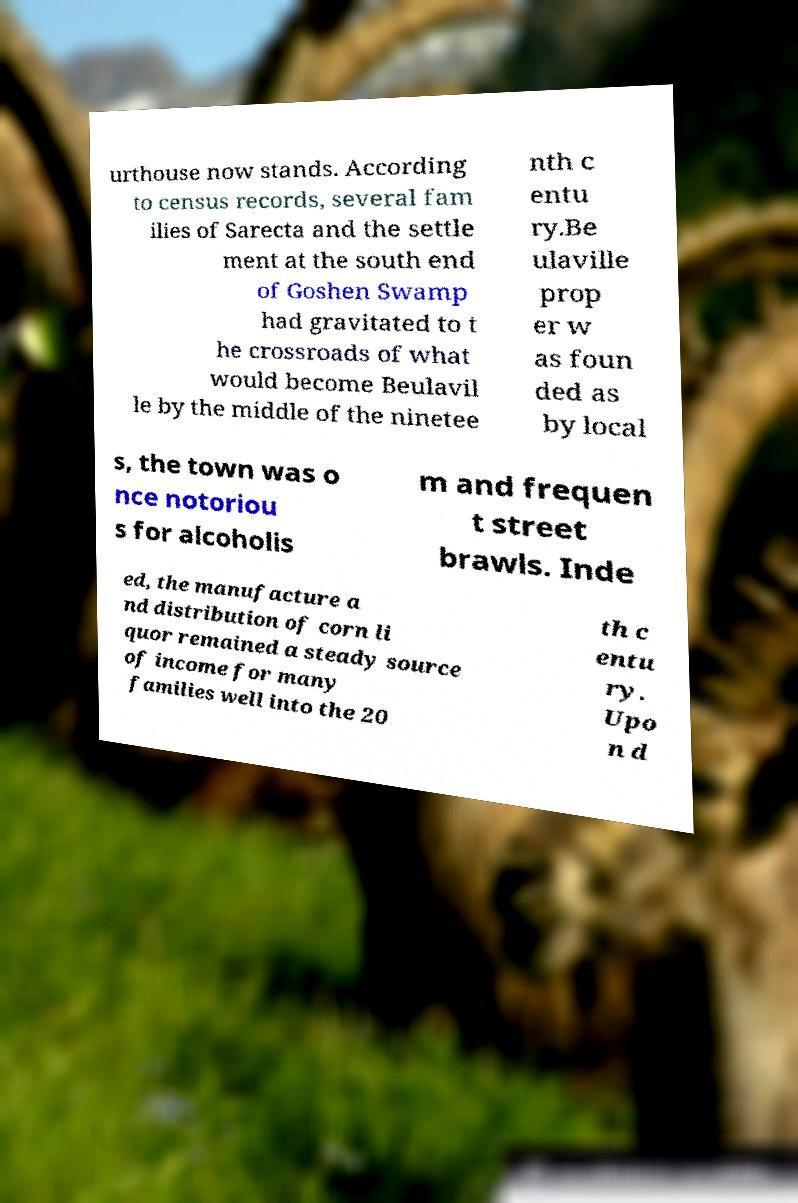What messages or text are displayed in this image? I need them in a readable, typed format. urthouse now stands. According to census records, several fam ilies of Sarecta and the settle ment at the south end of Goshen Swamp had gravitated to t he crossroads of what would become Beulavil le by the middle of the ninetee nth c entu ry.Be ulaville prop er w as foun ded as by local s, the town was o nce notoriou s for alcoholis m and frequen t street brawls. Inde ed, the manufacture a nd distribution of corn li quor remained a steady source of income for many families well into the 20 th c entu ry. Upo n d 